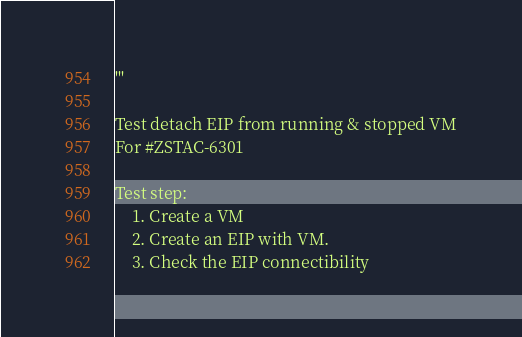Convert code to text. <code><loc_0><loc_0><loc_500><loc_500><_Python_>'''

Test detach EIP from running & stopped VM
For #ZSTAC-6301

Test step:
    1. Create a VM
    2. Create an EIP with VM.
    3. Check the EIP connectibility</code> 